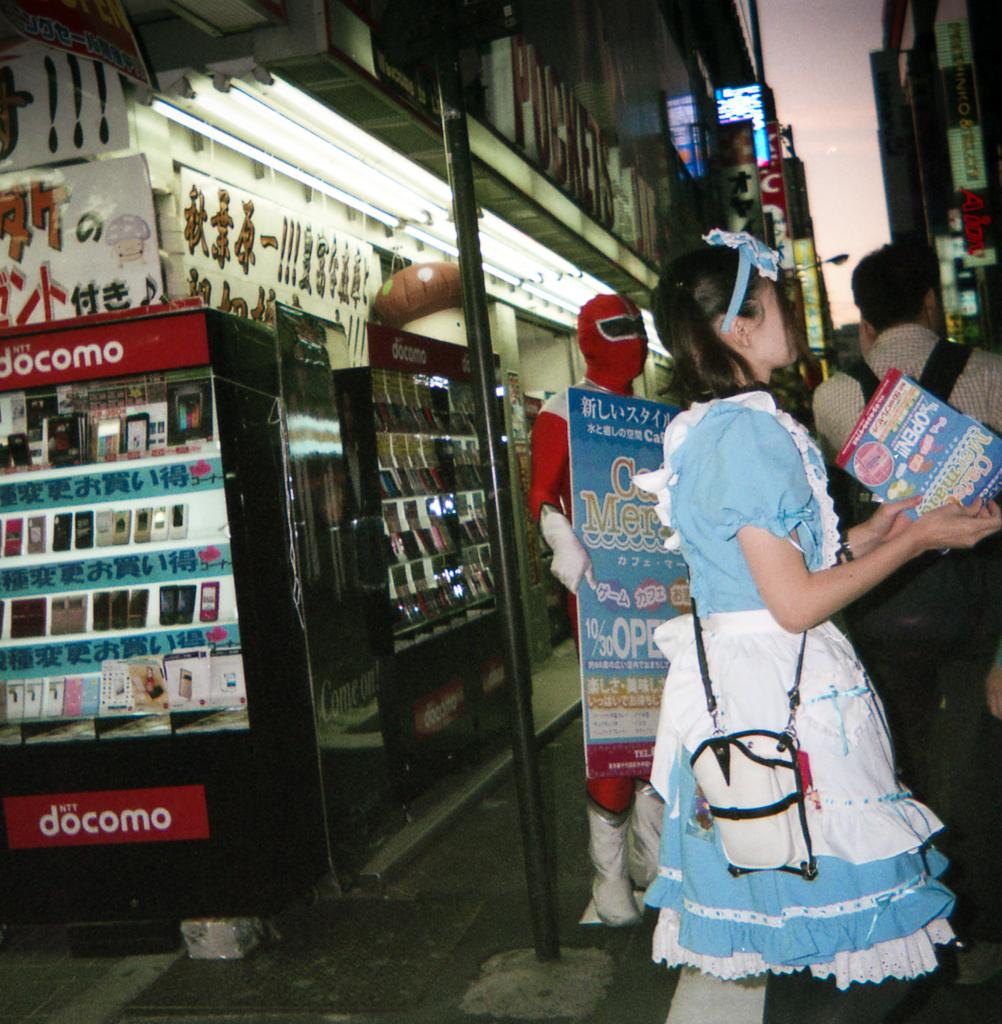Provide a one-sentence caption for the provided image. A woman wearing an Alice in Wonderland costume stands outside of a Docomo store. 